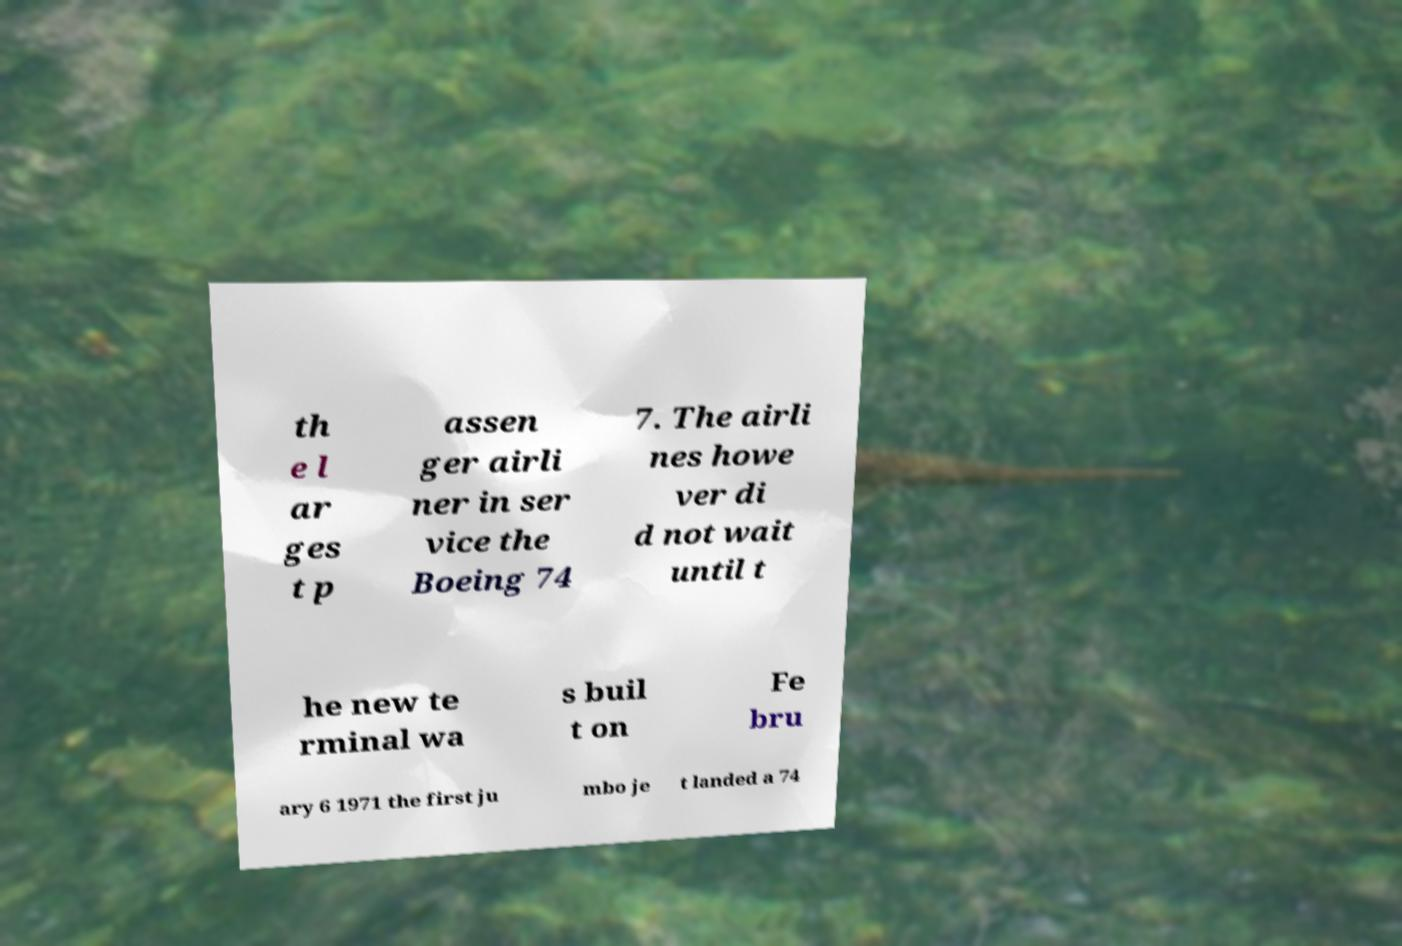What messages or text are displayed in this image? I need them in a readable, typed format. th e l ar ges t p assen ger airli ner in ser vice the Boeing 74 7. The airli nes howe ver di d not wait until t he new te rminal wa s buil t on Fe bru ary 6 1971 the first ju mbo je t landed a 74 